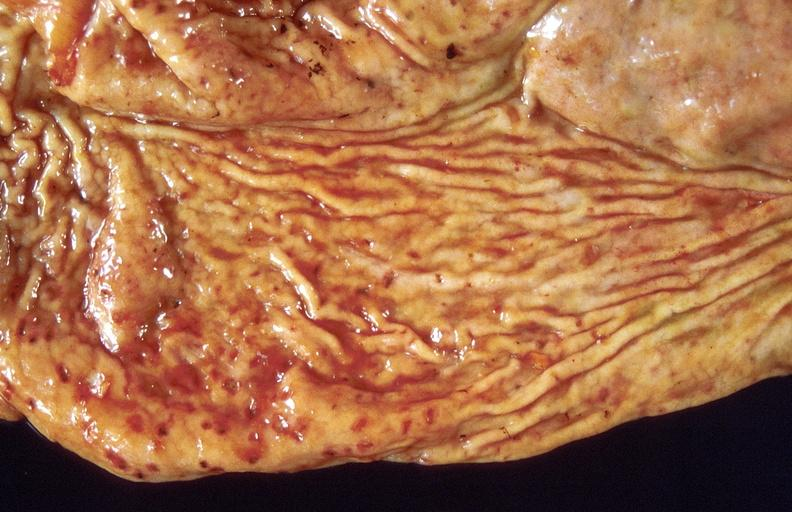what is present?
Answer the question using a single word or phrase. Gastrointestinal 